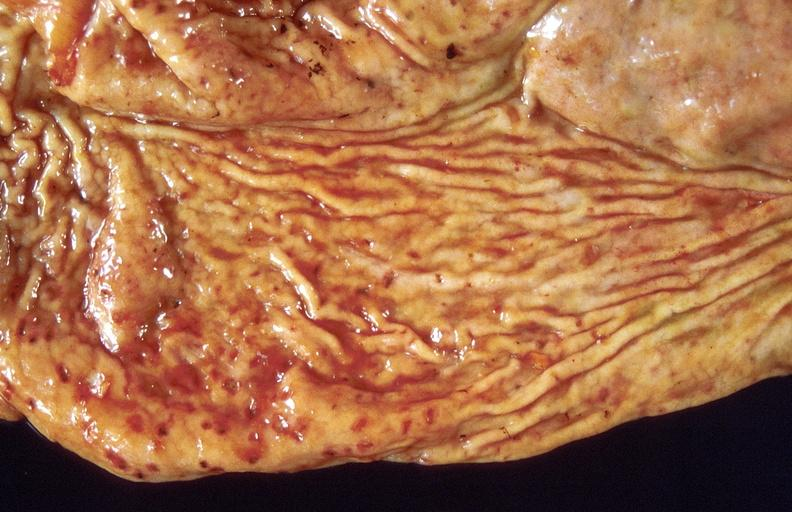what is present?
Answer the question using a single word or phrase. Gastrointestinal 